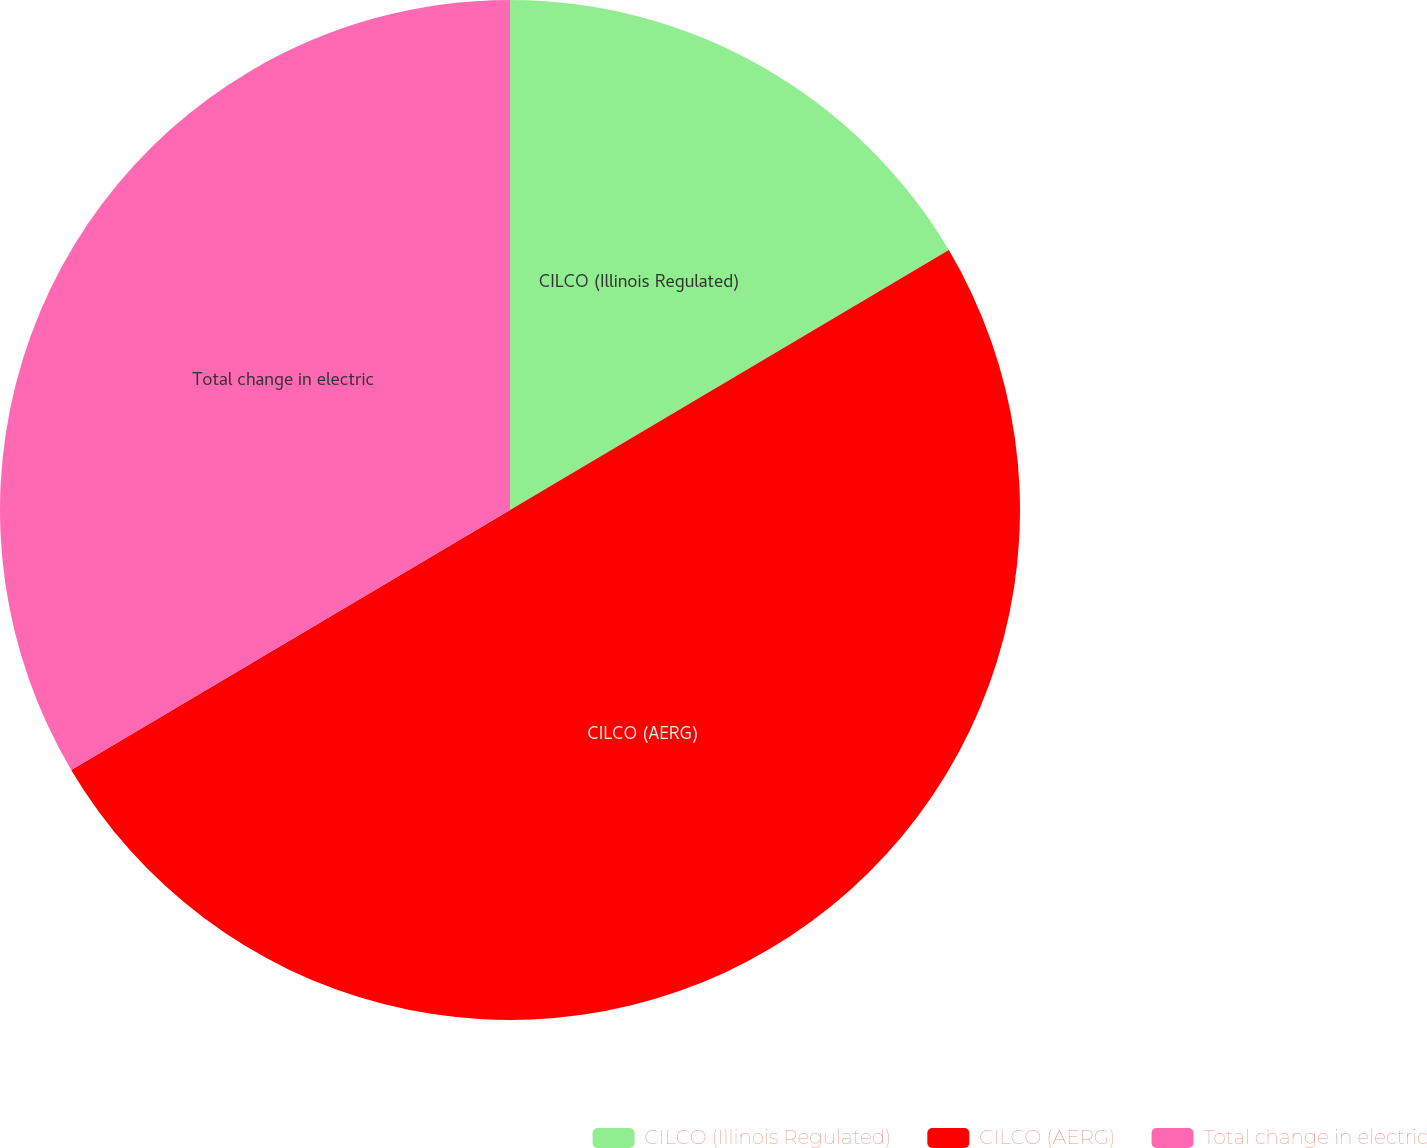<chart> <loc_0><loc_0><loc_500><loc_500><pie_chart><fcel>CILCO (Illinois Regulated)<fcel>CILCO (AERG)<fcel>Total change in electric<nl><fcel>16.49%<fcel>50.0%<fcel>33.51%<nl></chart> 